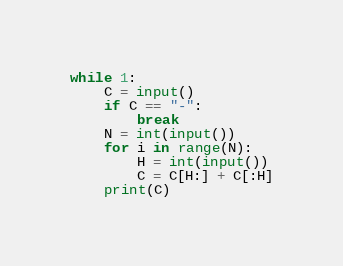Convert code to text. <code><loc_0><loc_0><loc_500><loc_500><_Python_>while 1:
    C = input()
    if C == "-":
        break
    N = int(input())
    for i in range(N):
        H = int(input())
        C = C[H:] + C[:H]
    print(C)

</code> 